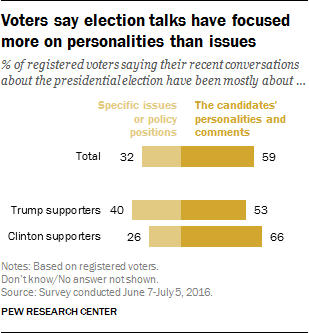Specify some key components in this picture. There are two bars that have values below 50, excluding 40. A recent survey indicated that 40% of Trump supporters hold a particular policy position on a specific issue. 